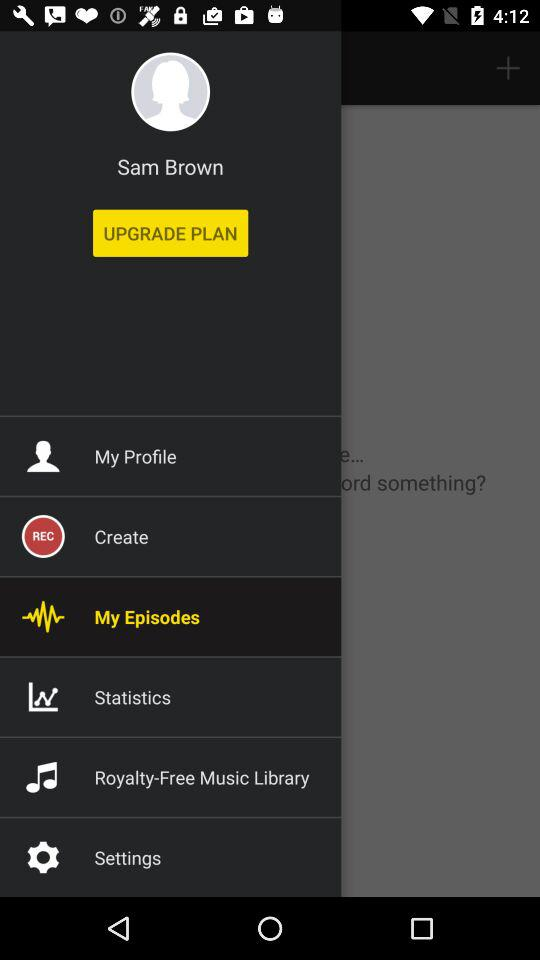What is the user name? The user name is Sam Brown. 